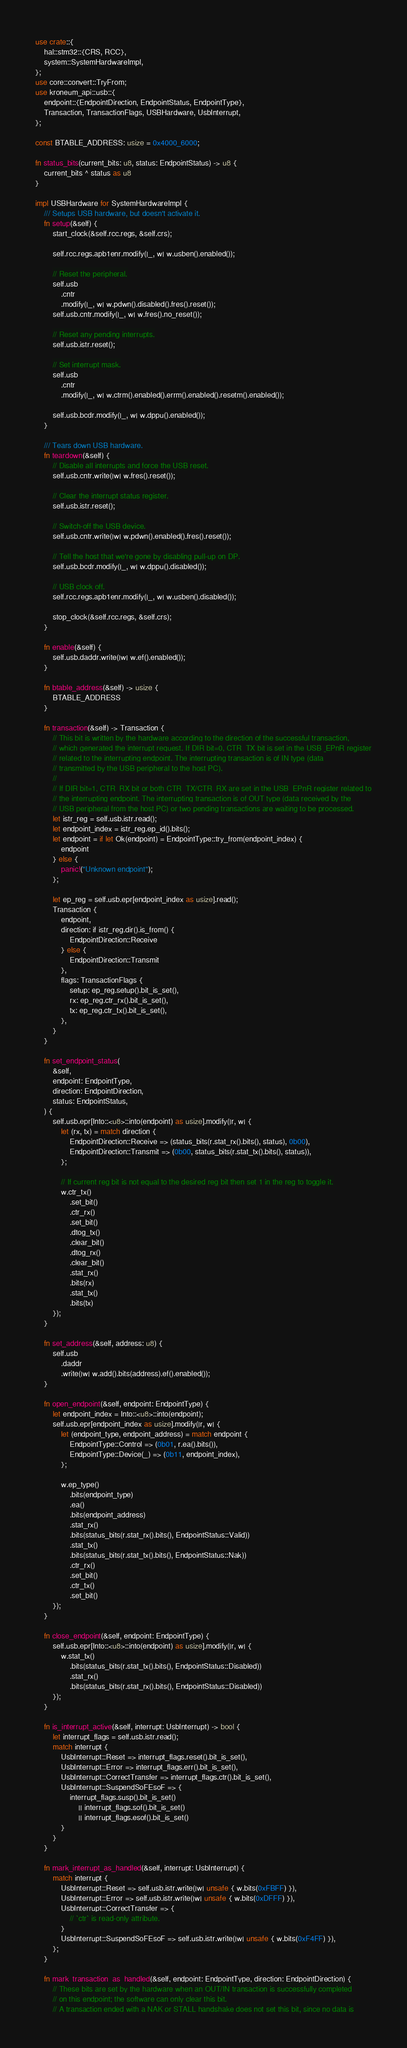<code> <loc_0><loc_0><loc_500><loc_500><_Rust_>use crate::{
    hal::stm32::{CRS, RCC},
    system::SystemHardwareImpl,
};
use core::convert::TryFrom;
use kroneum_api::usb::{
    endpoint::{EndpointDirection, EndpointStatus, EndpointType},
    Transaction, TransactionFlags, USBHardware, UsbInterrupt,
};

const BTABLE_ADDRESS: usize = 0x4000_6000;

fn status_bits(current_bits: u8, status: EndpointStatus) -> u8 {
    current_bits ^ status as u8
}

impl USBHardware for SystemHardwareImpl {
    /// Setups USB hardware, but doesn't activate it.
    fn setup(&self) {
        start_clock(&self.rcc.regs, &self.crs);

        self.rcc.regs.apb1enr.modify(|_, w| w.usben().enabled());

        // Reset the peripheral.
        self.usb
            .cntr
            .modify(|_, w| w.pdwn().disabled().fres().reset());
        self.usb.cntr.modify(|_, w| w.fres().no_reset());

        // Reset any pending interrupts.
        self.usb.istr.reset();

        // Set interrupt mask.
        self.usb
            .cntr
            .modify(|_, w| w.ctrm().enabled().errm().enabled().resetm().enabled());

        self.usb.bcdr.modify(|_, w| w.dppu().enabled());
    }

    /// Tears down USB hardware.
    fn teardown(&self) {
        // Disable all interrupts and force the USB reset.
        self.usb.cntr.write(|w| w.fres().reset());

        // Clear the interrupt status register.
        self.usb.istr.reset();

        // Switch-off the USB device.
        self.usb.cntr.write(|w| w.pdwn().enabled().fres().reset());

        // Tell the host that we're gone by disabling pull-up on DP.
        self.usb.bcdr.modify(|_, w| w.dppu().disabled());

        // USB clock off.
        self.rcc.regs.apb1enr.modify(|_, w| w.usben().disabled());

        stop_clock(&self.rcc.regs, &self.crs);
    }

    fn enable(&self) {
        self.usb.daddr.write(|w| w.ef().enabled());
    }

    fn btable_address(&self) -> usize {
        BTABLE_ADDRESS
    }

    fn transaction(&self) -> Transaction {
        // This bit is written by the hardware according to the direction of the successful transaction,
        // which generated the interrupt request. If DIR bit=0, CTR_TX bit is set in the USB_EPnR register
        // related to the interrupting endpoint. The interrupting transaction is of IN type (data
        // transmitted by the USB peripheral to the host PC).
        //
        // If DIR bit=1, CTR_RX bit or both CTR_TX/CTR_RX are set in the USB_EPnR register related to
        // the interrupting endpoint. The interrupting transaction is of OUT type (data received by the
        // USB peripheral from the host PC) or two pending transactions are waiting to be processed.
        let istr_reg = self.usb.istr.read();
        let endpoint_index = istr_reg.ep_id().bits();
        let endpoint = if let Ok(endpoint) = EndpointType::try_from(endpoint_index) {
            endpoint
        } else {
            panic!("Unknown endpoint");
        };

        let ep_reg = self.usb.epr[endpoint_index as usize].read();
        Transaction {
            endpoint,
            direction: if istr_reg.dir().is_from() {
                EndpointDirection::Receive
            } else {
                EndpointDirection::Transmit
            },
            flags: TransactionFlags {
                setup: ep_reg.setup().bit_is_set(),
                rx: ep_reg.ctr_rx().bit_is_set(),
                tx: ep_reg.ctr_tx().bit_is_set(),
            },
        }
    }

    fn set_endpoint_status(
        &self,
        endpoint: EndpointType,
        direction: EndpointDirection,
        status: EndpointStatus,
    ) {
        self.usb.epr[Into::<u8>::into(endpoint) as usize].modify(|r, w| {
            let (rx, tx) = match direction {
                EndpointDirection::Receive => (status_bits(r.stat_rx().bits(), status), 0b00),
                EndpointDirection::Transmit => (0b00, status_bits(r.stat_tx().bits(), status)),
            };

            // If current reg bit is not equal to the desired reg bit then set 1 in the reg to toggle it.
            w.ctr_tx()
                .set_bit()
                .ctr_rx()
                .set_bit()
                .dtog_tx()
                .clear_bit()
                .dtog_rx()
                .clear_bit()
                .stat_rx()
                .bits(rx)
                .stat_tx()
                .bits(tx)
        });
    }

    fn set_address(&self, address: u8) {
        self.usb
            .daddr
            .write(|w| w.add().bits(address).ef().enabled());
    }

    fn open_endpoint(&self, endpoint: EndpointType) {
        let endpoint_index = Into::<u8>::into(endpoint);
        self.usb.epr[endpoint_index as usize].modify(|r, w| {
            let (endpoint_type, endpoint_address) = match endpoint {
                EndpointType::Control => (0b01, r.ea().bits()),
                EndpointType::Device(_) => (0b11, endpoint_index),
            };

            w.ep_type()
                .bits(endpoint_type)
                .ea()
                .bits(endpoint_address)
                .stat_rx()
                .bits(status_bits(r.stat_rx().bits(), EndpointStatus::Valid))
                .stat_tx()
                .bits(status_bits(r.stat_tx().bits(), EndpointStatus::Nak))
                .ctr_rx()
                .set_bit()
                .ctr_tx()
                .set_bit()
        });
    }

    fn close_endpoint(&self, endpoint: EndpointType) {
        self.usb.epr[Into::<u8>::into(endpoint) as usize].modify(|r, w| {
            w.stat_tx()
                .bits(status_bits(r.stat_tx().bits(), EndpointStatus::Disabled))
                .stat_rx()
                .bits(status_bits(r.stat_rx().bits(), EndpointStatus::Disabled))
        });
    }

    fn is_interrupt_active(&self, interrupt: UsbInterrupt) -> bool {
        let interrupt_flags = self.usb.istr.read();
        match interrupt {
            UsbInterrupt::Reset => interrupt_flags.reset().bit_is_set(),
            UsbInterrupt::Error => interrupt_flags.err().bit_is_set(),
            UsbInterrupt::CorrectTransfer => interrupt_flags.ctr().bit_is_set(),
            UsbInterrupt::SuspendSoFEsoF => {
                interrupt_flags.susp().bit_is_set()
                    || interrupt_flags.sof().bit_is_set()
                    || interrupt_flags.esof().bit_is_set()
            }
        }
    }

    fn mark_interrupt_as_handled(&self, interrupt: UsbInterrupt) {
        match interrupt {
            UsbInterrupt::Reset => self.usb.istr.write(|w| unsafe { w.bits(0xFBFF) }),
            UsbInterrupt::Error => self.usb.istr.write(|w| unsafe { w.bits(0xDFFF) }),
            UsbInterrupt::CorrectTransfer => {
                // `ctr` is read-only attribute.
            }
            UsbInterrupt::SuspendSoFEsoF => self.usb.istr.write(|w| unsafe { w.bits(0xF4FF) }),
        };
    }

    fn mark_transaction_as_handled(&self, endpoint: EndpointType, direction: EndpointDirection) {
        // These bits are set by the hardware when an OUT/IN transaction is successfully completed
        // on this endpoint; the software can only clear this bit.
        // A transaction ended with a NAK or STALL handshake does not set this bit, since no data is</code> 